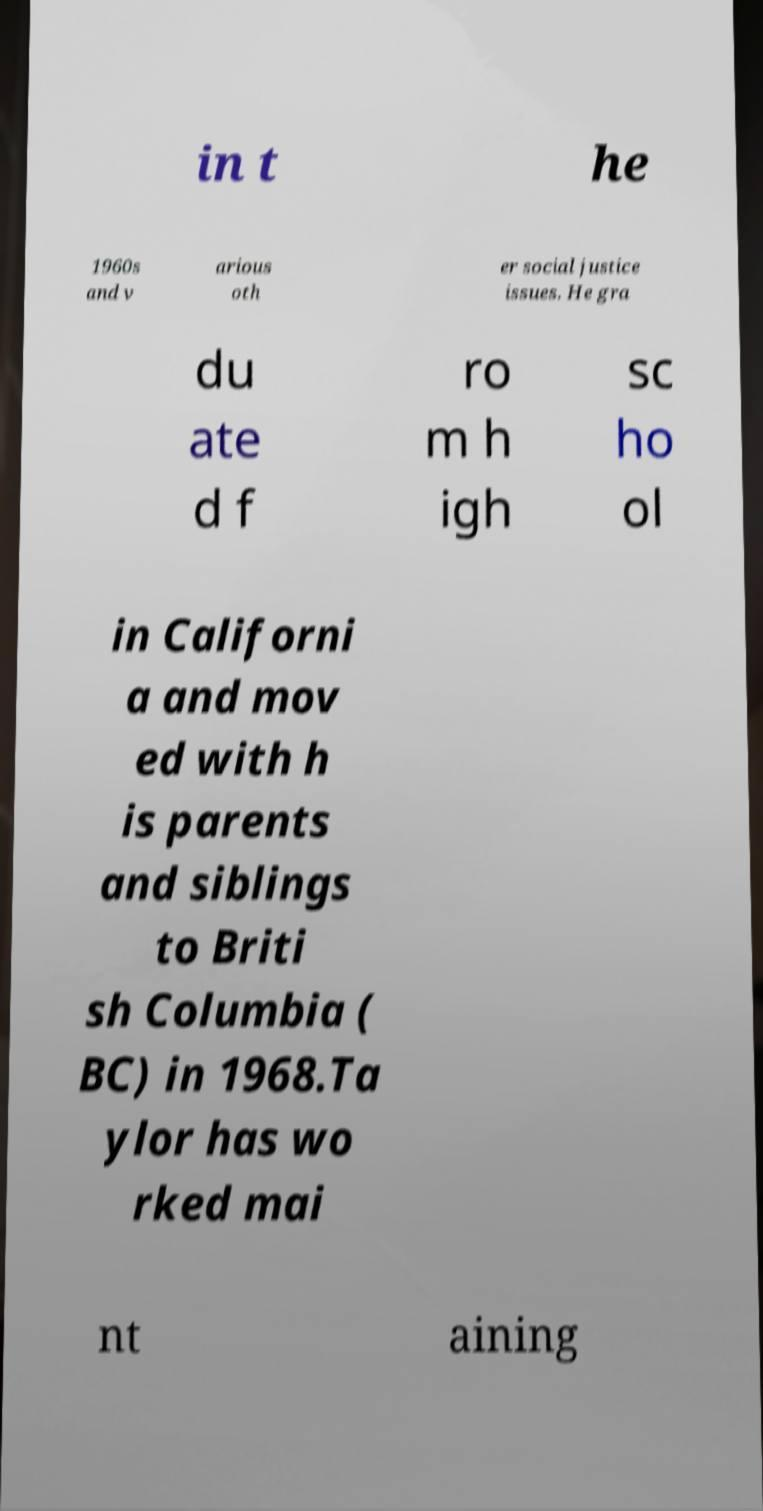Please identify and transcribe the text found in this image. in t he 1960s and v arious oth er social justice issues. He gra du ate d f ro m h igh sc ho ol in Californi a and mov ed with h is parents and siblings to Briti sh Columbia ( BC) in 1968.Ta ylor has wo rked mai nt aining 